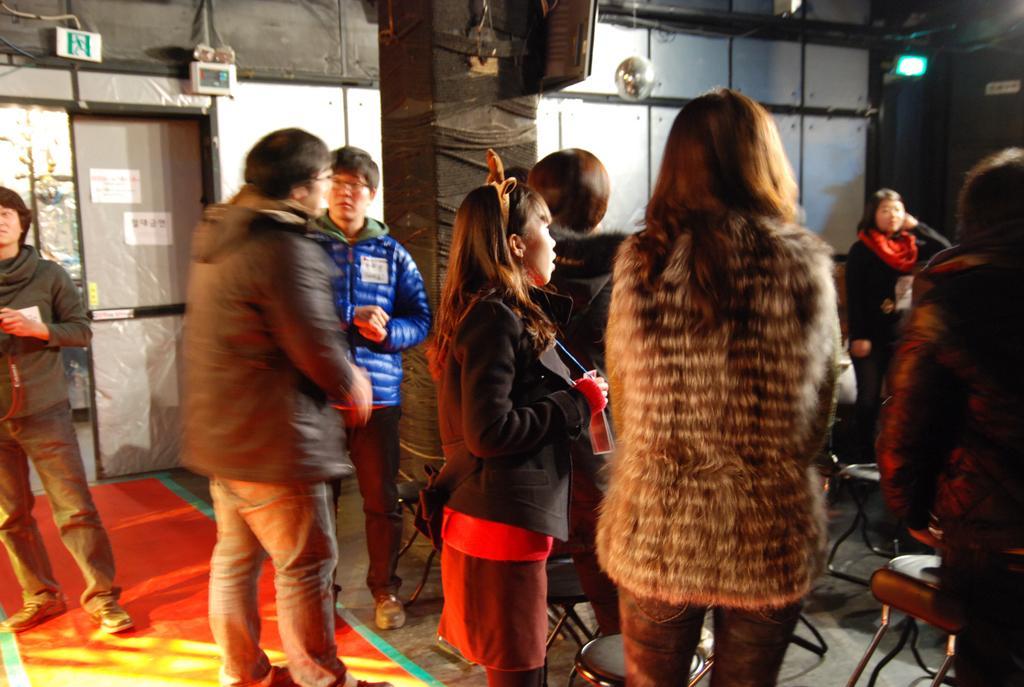Please provide a concise description of this image. In this picture we can see some people are standing, on the left side there is a door and a board, we can see a pillar in the middle, on the right side there are some chairs, we can see a light in the background. 